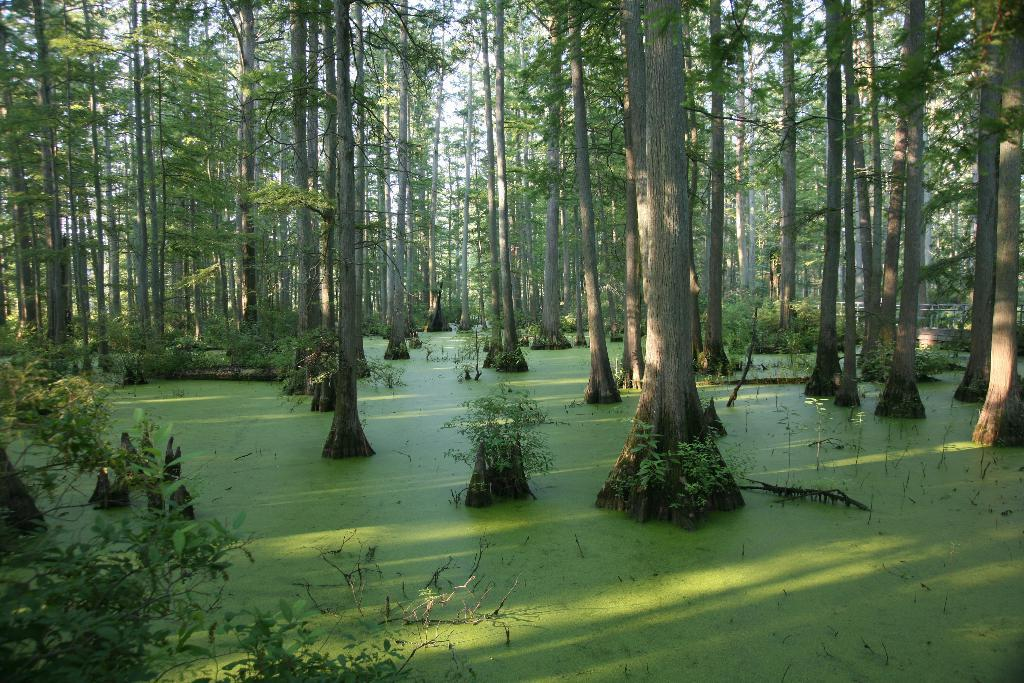What is the primary element in the image? There is water in the image. How would you describe the color of the water? The water appears to be green in color. What is unique about the trees in the image? The trees are on the surface of the water. What colors can be seen on the trees? The trees have green and grey colors. What can be seen in the background of the image? The sky is visible in the background of the image. Where is the store located in the image? There is no store present in the image; it features water with trees on its surface and a visible sky in the background. 